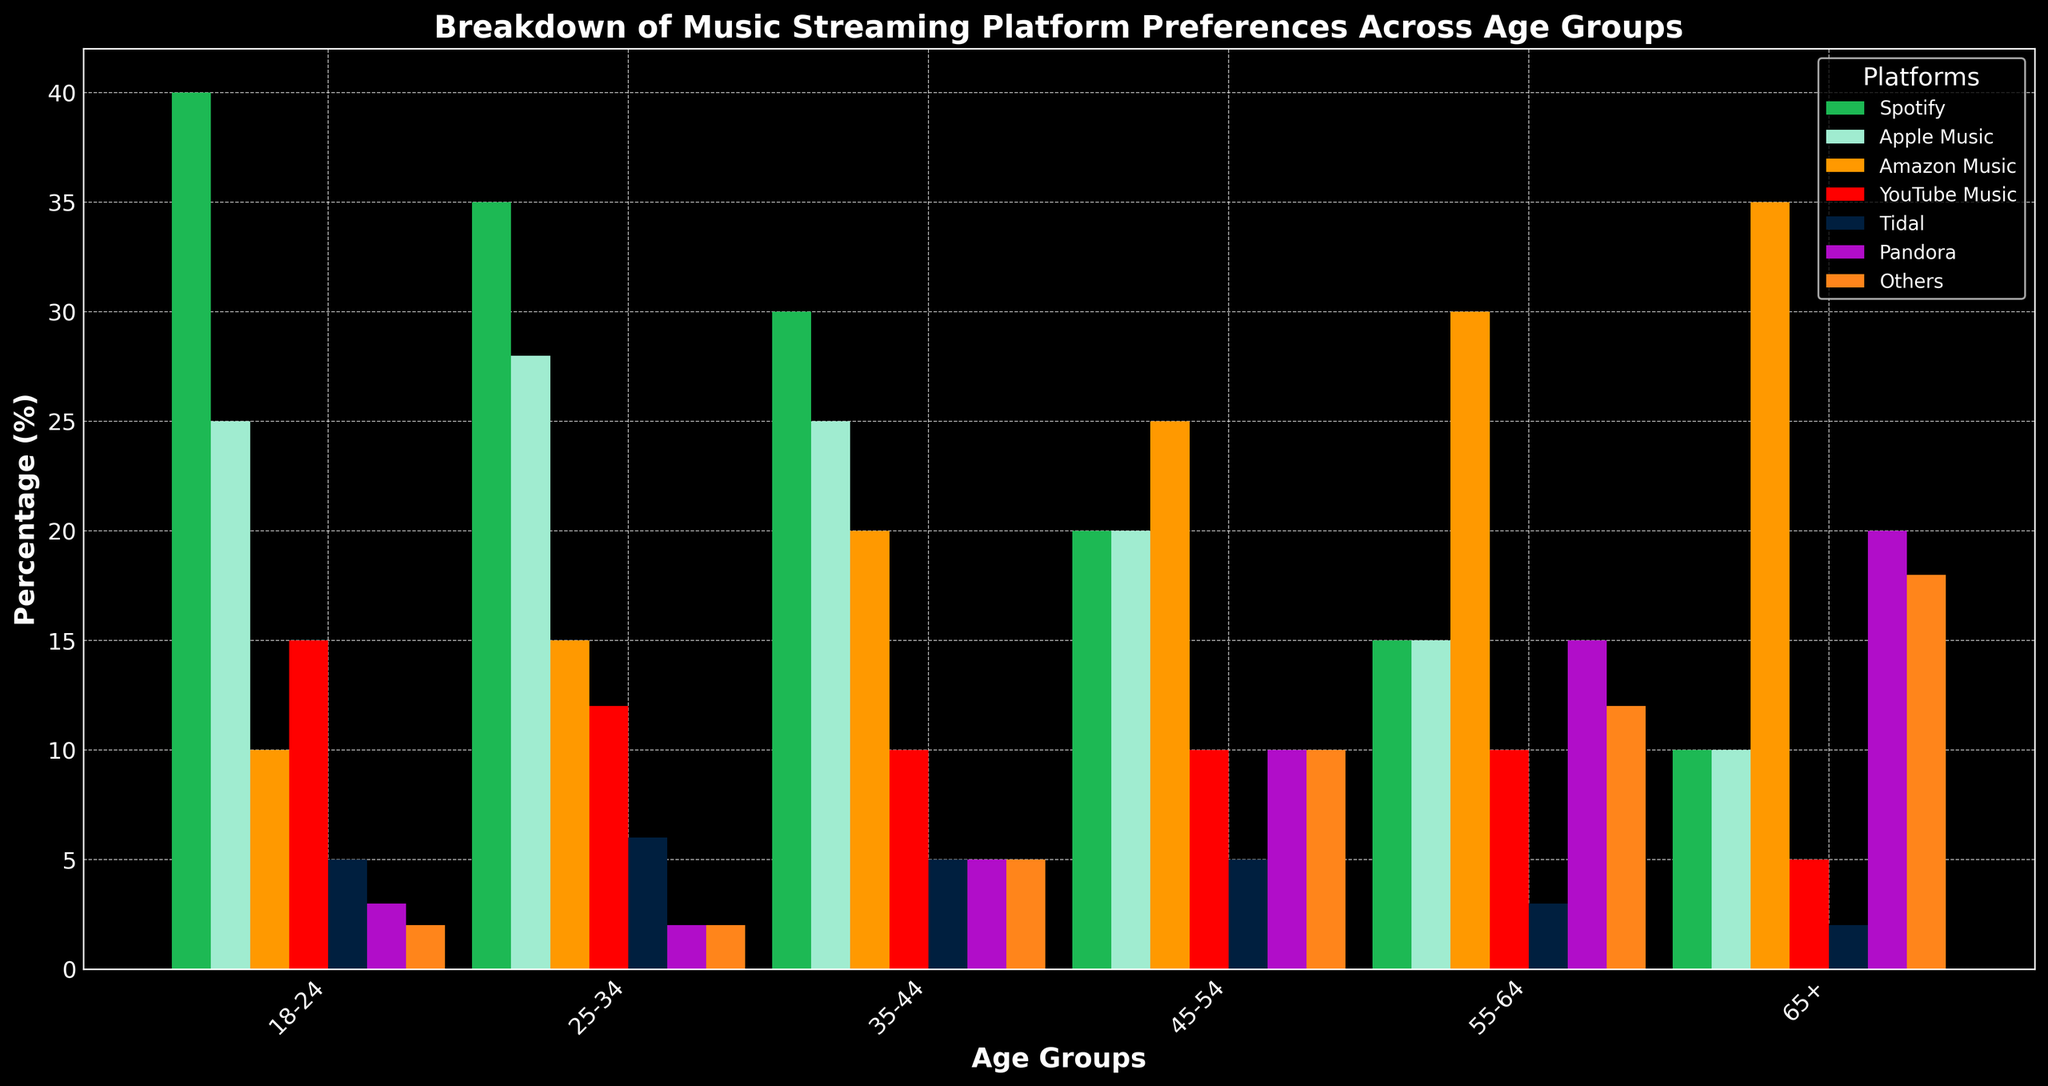Which age group prefers Spotify the most? By examining the height of the bars, the age group with the tallest green bar represents Spotify's highest preference. Here, the 18-24 age group has the tallest green bar.
Answer: 18-24 Which platform is most preferred by the 65+ age group? By looking at the 65+ category, we can compare the heights of the bars to find the tallest one, which indicates the preferred platform. The tallest bar is for Amazon Music.
Answer: Amazon Music What is the combined preference percentage for Apple Music and YouTube Music among the 25-34 age group? For the 25-34 age group, the bar heights for Apple Music and YouTube Music show 28% and 12%, respectively. Adding them gives 28 + 12 = 40%.
Answer: 40% Which age group has a higher preference for Tidal compared to Pandora? By comparing the bar heights for Tidal and Pandora within each age group, we see that the 18-24, 25-34, and 35-44 age groups prefer Tidal over Pandora. For any middle-aged or older group, preference for Tidal isn't higher than Pandora.
Answer: 18-24, 25-34, 35-44 How does the preference for Spotify change as the age group increases? Observing the trend of the green bars representing Spotify from left to right (from younger to older age groups), the height decreases, showing a decline in preference with higher age groups.
Answer: Decreases Which platforms have the same preference percentage in the 35-44 age group? For the 35-44 age group, examining the bar heights shows that both Tidal and Pandora have bars of the same height, indicating equal preference at 5%.
Answer: Tidal and Pandora Between Amazon Music and YouTube Music, which one is more preferred in the 45-54 age group? By comparing the heights of the bars for Amazon Music and YouTube Music within the 45-54 age group, the taller bar indicates Amazon Music is more preferred.
Answer: Amazon Music 